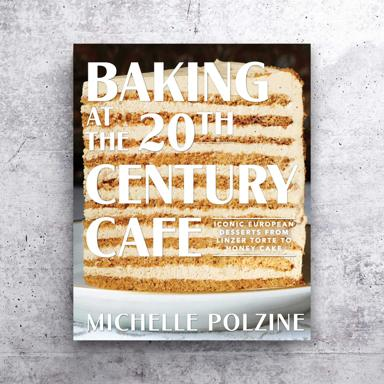What is the name of the book or event mentioned in the image? The image features the book titled "Baking at the 20th Century Cafe: Iconic European Desserts" authored by Michelle Polzine. This book delves into timeless dessert recipes inspired by various European traditions, bringing a slice of European cafe culture right into your kitchen. 